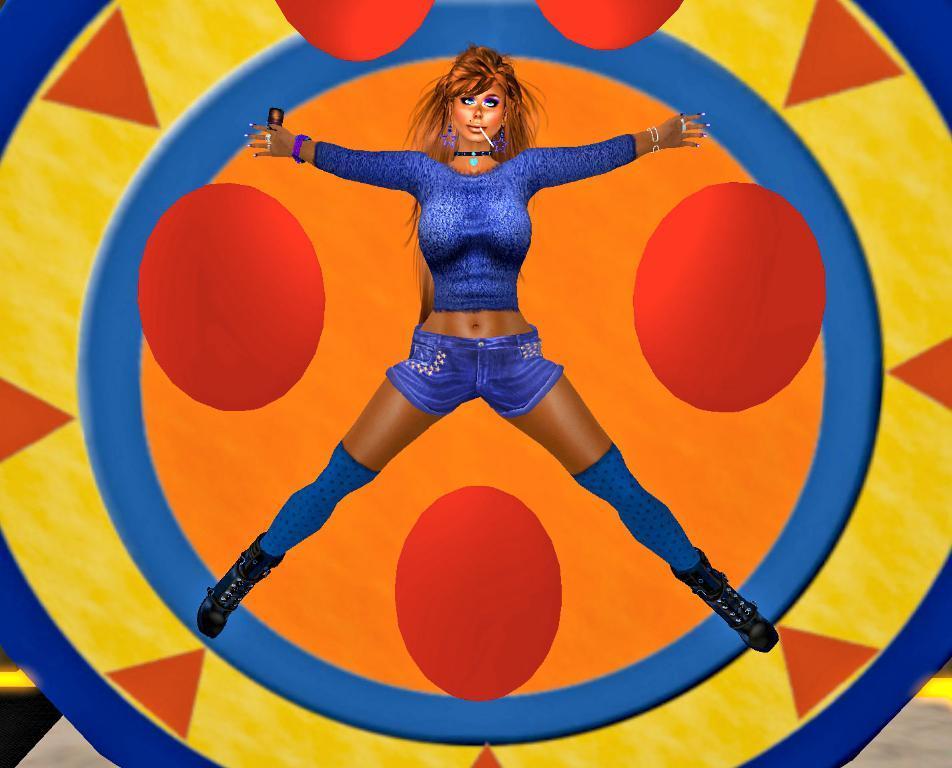Can you describe this image briefly? This is an animated image. In which, there is a woman in a violet color dress on a circular device. 